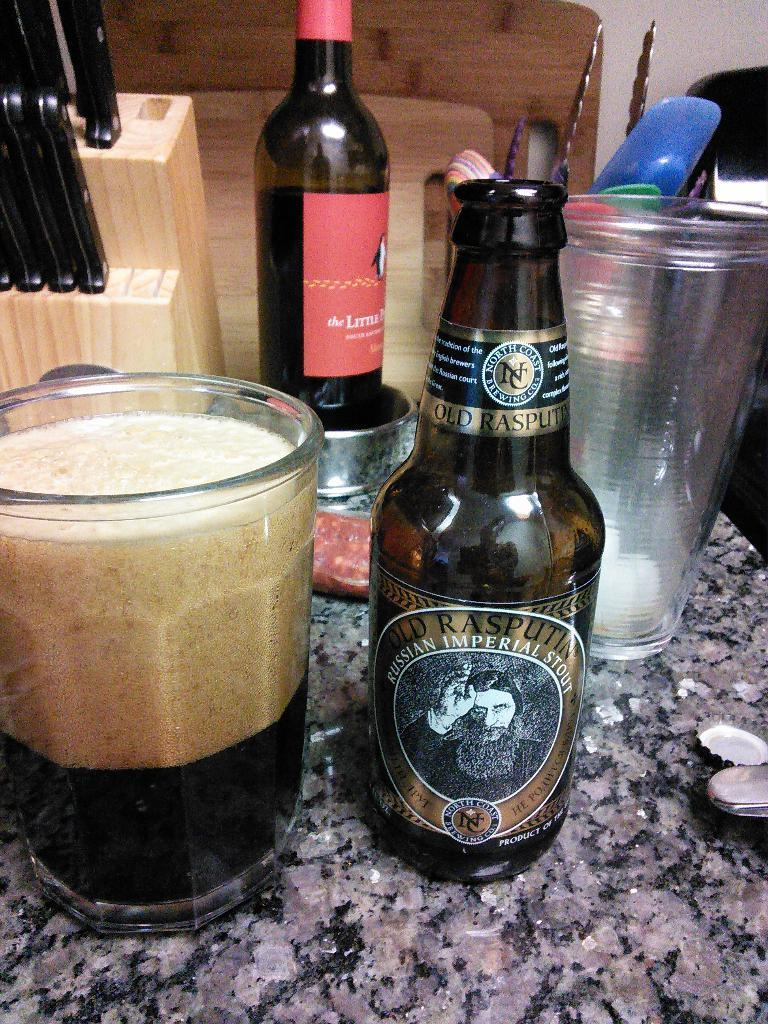<image>
Present a compact description of the photo's key features. A messy kitchen counter with a Russian Imperial Stout beer bottle. 